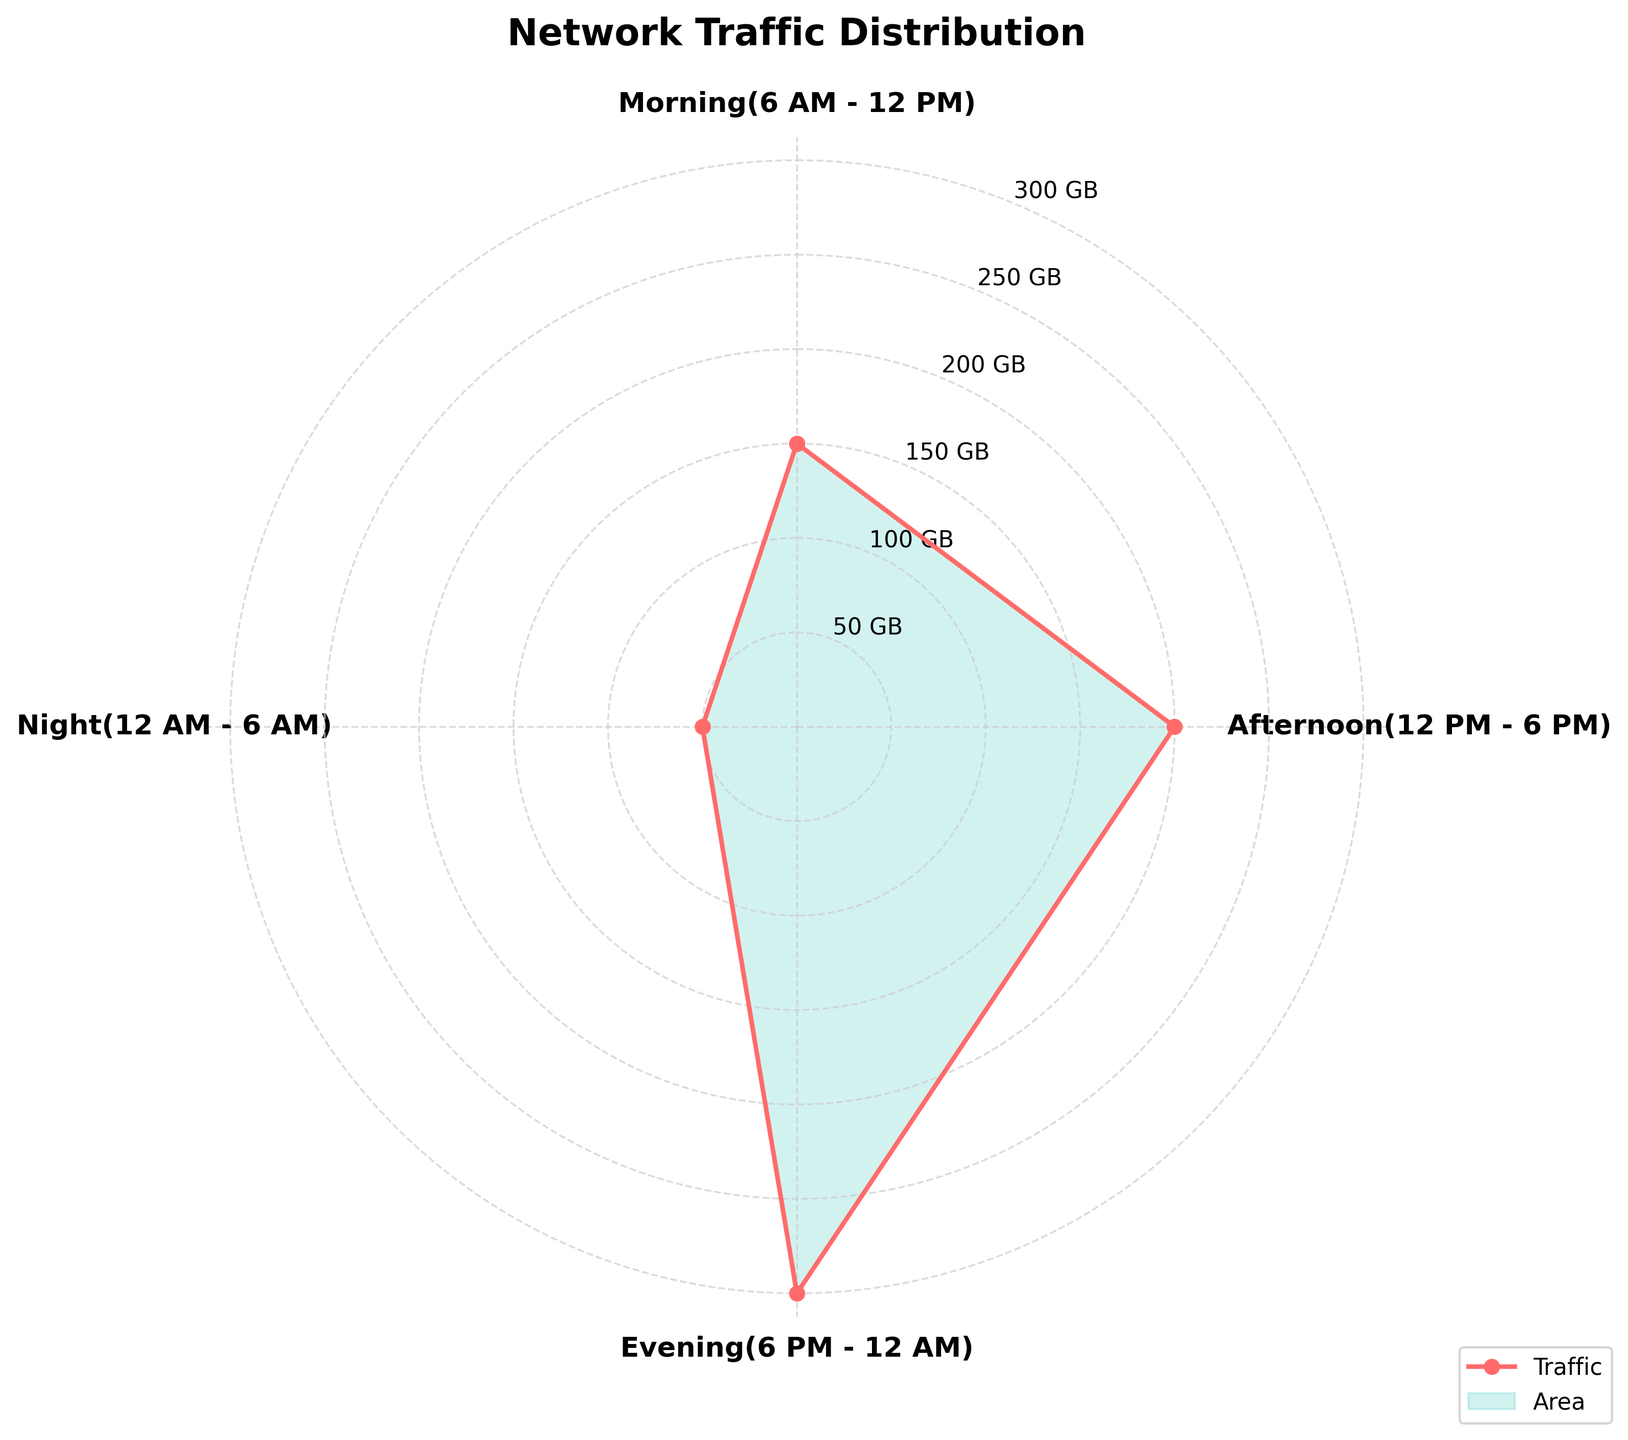What's the title of the figure? The title is written at the top of the figure. It is clearly displayed in bold and larger font size than other text elements.
Answer: Network Traffic Distribution How many time periods are shown in the figure? The figure divides a day into segments marked on the circular plot, with labeled categories corresponding to each time period.
Answer: 4 Which time period has the highest network traffic? Observing the labeled segments, the longest one represents the highest traffic.
Answer: Evening What is the network traffic for the Night time period? The value represented within the Night segment shows the shortest segment on the plot and is referenced on the radial ticks.
Answer: 50 GB What is the difference in network traffic between Morning and Afternoon? Subtract the Morning traffic value (150 GB) from the Afternoon traffic value (200 GB).
Answer: 50 GB How does the size of the peak traffic in the Evening compare to the traffic in the Afternoon? Evening traffic (300 GB) is shown with a segment much longer than the Afternoon (200 GB). Subtract the two values to find the difference.
Answer: 100 GB What is the average network traffic over the four time periods? Add the network traffic values for each time period: 150 + 200 + 300 + 50, then divide by 4.
Answer: 175 GB What proportion of the total network traffic occurs in the Morning? The total network traffic is 700 GB (150 + 200 + 300 + 50). To find the proportion of Morning traffic: (150 / 700) * 100%.
Answer: 21.4% In which time period is the network traffic significantly lower than the others? Observing each segment's length and number representation, the night segment is considerably shorter than the others.
Answer: Night Which two time periods combined account for exactly half of the total network traffic? Calculate the traffic for all possible combinations until their sum equals half the total (700 / 2 = 350). Morning (150) + Evening (300) = 450 is too high; Morning (150) + Afternoon (200) = 350.
Answer: Morning and Afternoon 